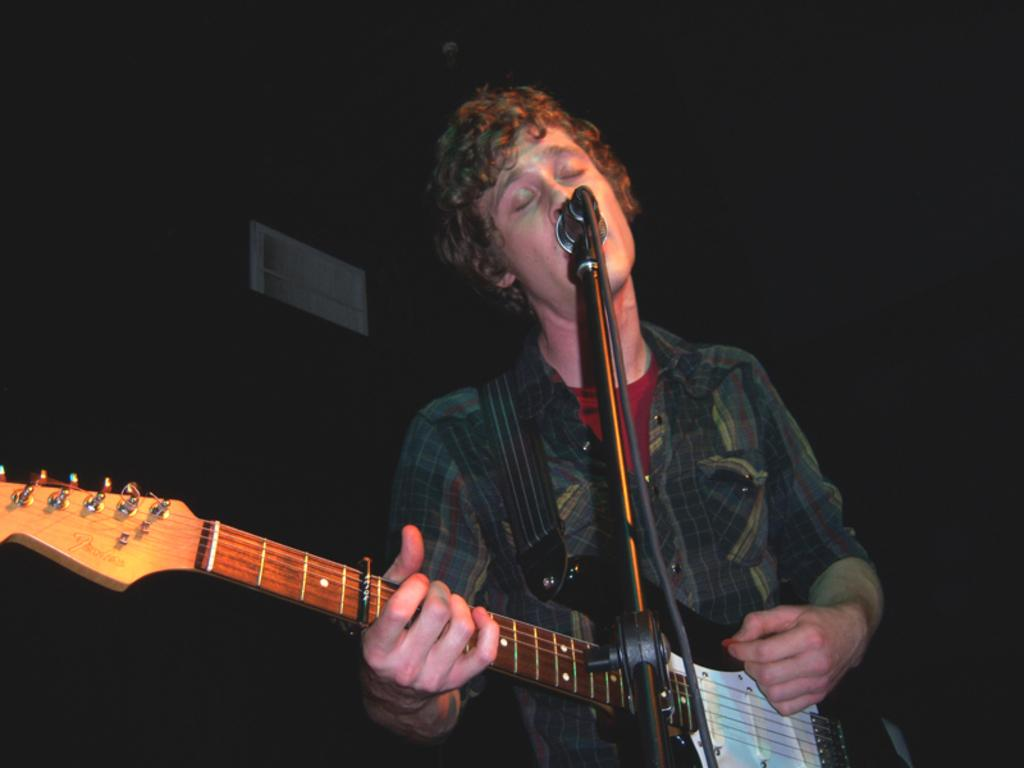What is the overall color scheme of the background in the image? The background of the image is dark. Can you describe the person in the image? There is a man standing in the image. What is the man doing in the image? The man is playing a guitar and is in front of a microphone. How many eggs are on the table next to the man in the image? There are no eggs present in the image. Is the man sleeping in the image? No, the man is not sleeping in the image; he is playing a guitar and standing in front of a microphone. 